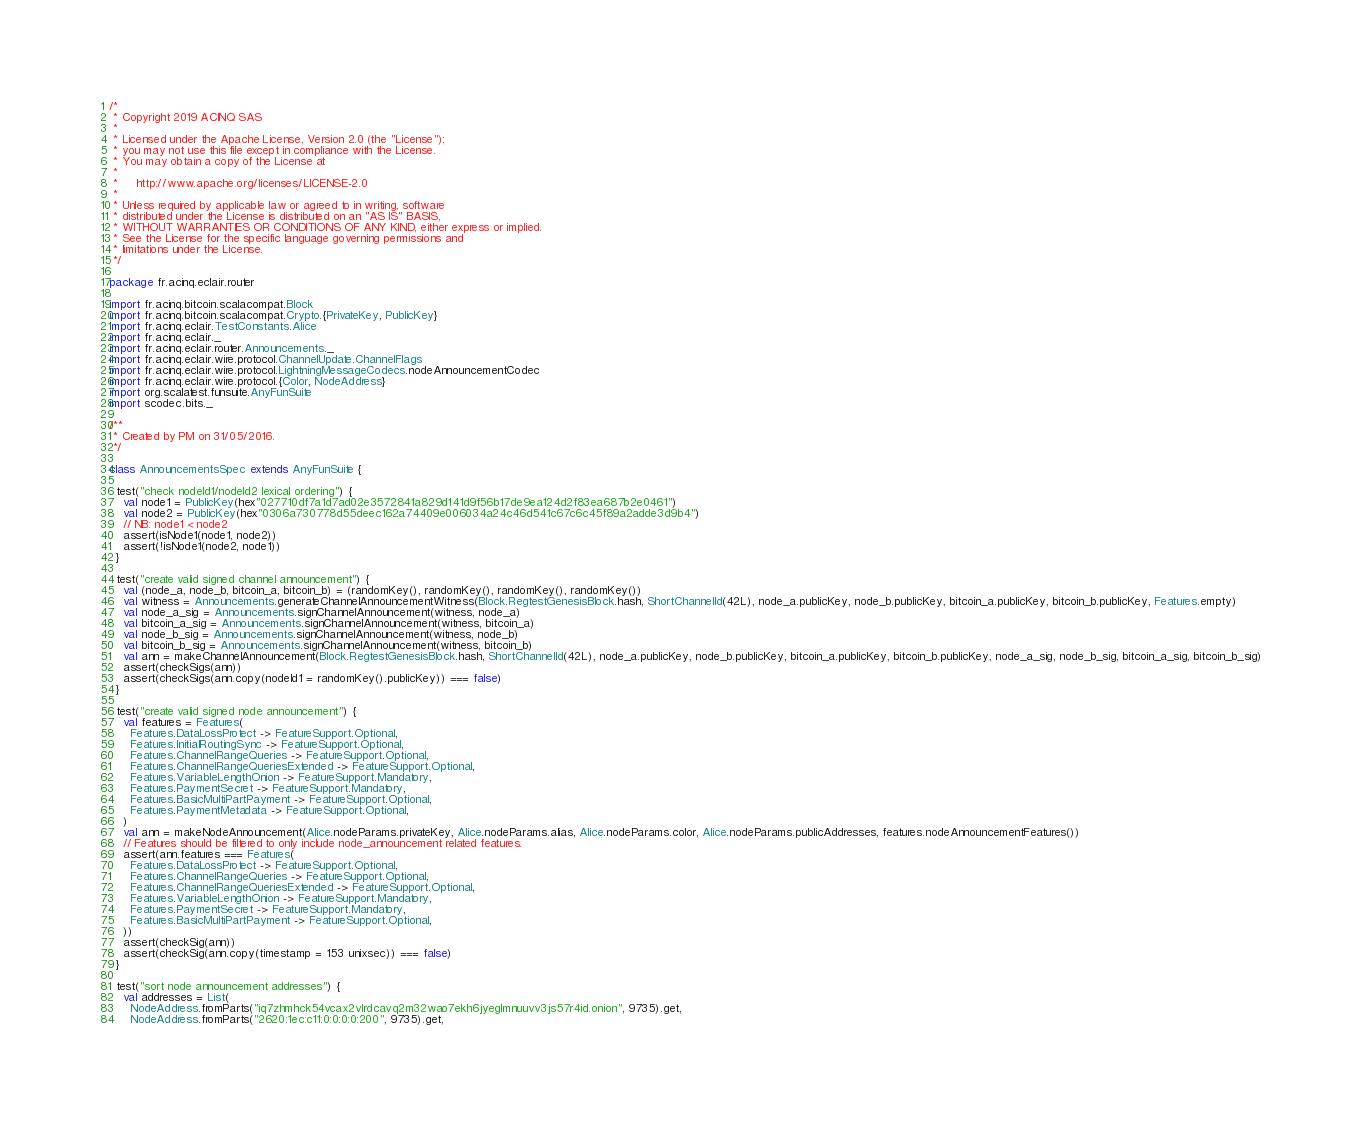Convert code to text. <code><loc_0><loc_0><loc_500><loc_500><_Scala_>/*
 * Copyright 2019 ACINQ SAS
 *
 * Licensed under the Apache License, Version 2.0 (the "License");
 * you may not use this file except in compliance with the License.
 * You may obtain a copy of the License at
 *
 *     http://www.apache.org/licenses/LICENSE-2.0
 *
 * Unless required by applicable law or agreed to in writing, software
 * distributed under the License is distributed on an "AS IS" BASIS,
 * WITHOUT WARRANTIES OR CONDITIONS OF ANY KIND, either express or implied.
 * See the License for the specific language governing permissions and
 * limitations under the License.
 */

package fr.acinq.eclair.router

import fr.acinq.bitcoin.scalacompat.Block
import fr.acinq.bitcoin.scalacompat.Crypto.{PrivateKey, PublicKey}
import fr.acinq.eclair.TestConstants.Alice
import fr.acinq.eclair._
import fr.acinq.eclair.router.Announcements._
import fr.acinq.eclair.wire.protocol.ChannelUpdate.ChannelFlags
import fr.acinq.eclair.wire.protocol.LightningMessageCodecs.nodeAnnouncementCodec
import fr.acinq.eclair.wire.protocol.{Color, NodeAddress}
import org.scalatest.funsuite.AnyFunSuite
import scodec.bits._

/**
 * Created by PM on 31/05/2016.
 */

class AnnouncementsSpec extends AnyFunSuite {

  test("check nodeId1/nodeId2 lexical ordering") {
    val node1 = PublicKey(hex"027710df7a1d7ad02e3572841a829d141d9f56b17de9ea124d2f83ea687b2e0461")
    val node2 = PublicKey(hex"0306a730778d55deec162a74409e006034a24c46d541c67c6c45f89a2adde3d9b4")
    // NB: node1 < node2
    assert(isNode1(node1, node2))
    assert(!isNode1(node2, node1))
  }

  test("create valid signed channel announcement") {
    val (node_a, node_b, bitcoin_a, bitcoin_b) = (randomKey(), randomKey(), randomKey(), randomKey())
    val witness = Announcements.generateChannelAnnouncementWitness(Block.RegtestGenesisBlock.hash, ShortChannelId(42L), node_a.publicKey, node_b.publicKey, bitcoin_a.publicKey, bitcoin_b.publicKey, Features.empty)
    val node_a_sig = Announcements.signChannelAnnouncement(witness, node_a)
    val bitcoin_a_sig = Announcements.signChannelAnnouncement(witness, bitcoin_a)
    val node_b_sig = Announcements.signChannelAnnouncement(witness, node_b)
    val bitcoin_b_sig = Announcements.signChannelAnnouncement(witness, bitcoin_b)
    val ann = makeChannelAnnouncement(Block.RegtestGenesisBlock.hash, ShortChannelId(42L), node_a.publicKey, node_b.publicKey, bitcoin_a.publicKey, bitcoin_b.publicKey, node_a_sig, node_b_sig, bitcoin_a_sig, bitcoin_b_sig)
    assert(checkSigs(ann))
    assert(checkSigs(ann.copy(nodeId1 = randomKey().publicKey)) === false)
  }

  test("create valid signed node announcement") {
    val features = Features(
      Features.DataLossProtect -> FeatureSupport.Optional,
      Features.InitialRoutingSync -> FeatureSupport.Optional,
      Features.ChannelRangeQueries -> FeatureSupport.Optional,
      Features.ChannelRangeQueriesExtended -> FeatureSupport.Optional,
      Features.VariableLengthOnion -> FeatureSupport.Mandatory,
      Features.PaymentSecret -> FeatureSupport.Mandatory,
      Features.BasicMultiPartPayment -> FeatureSupport.Optional,
      Features.PaymentMetadata -> FeatureSupport.Optional,
    )
    val ann = makeNodeAnnouncement(Alice.nodeParams.privateKey, Alice.nodeParams.alias, Alice.nodeParams.color, Alice.nodeParams.publicAddresses, features.nodeAnnouncementFeatures())
    // Features should be filtered to only include node_announcement related features.
    assert(ann.features === Features(
      Features.DataLossProtect -> FeatureSupport.Optional,
      Features.ChannelRangeQueries -> FeatureSupport.Optional,
      Features.ChannelRangeQueriesExtended -> FeatureSupport.Optional,
      Features.VariableLengthOnion -> FeatureSupport.Mandatory,
      Features.PaymentSecret -> FeatureSupport.Mandatory,
      Features.BasicMultiPartPayment -> FeatureSupport.Optional,
    ))
    assert(checkSig(ann))
    assert(checkSig(ann.copy(timestamp = 153 unixsec)) === false)
  }

  test("sort node announcement addresses") {
    val addresses = List(
      NodeAddress.fromParts("iq7zhmhck54vcax2vlrdcavq2m32wao7ekh6jyeglmnuuvv3js57r4id.onion", 9735).get,
      NodeAddress.fromParts("2620:1ec:c11:0:0:0:0:200", 9735).get,</code> 